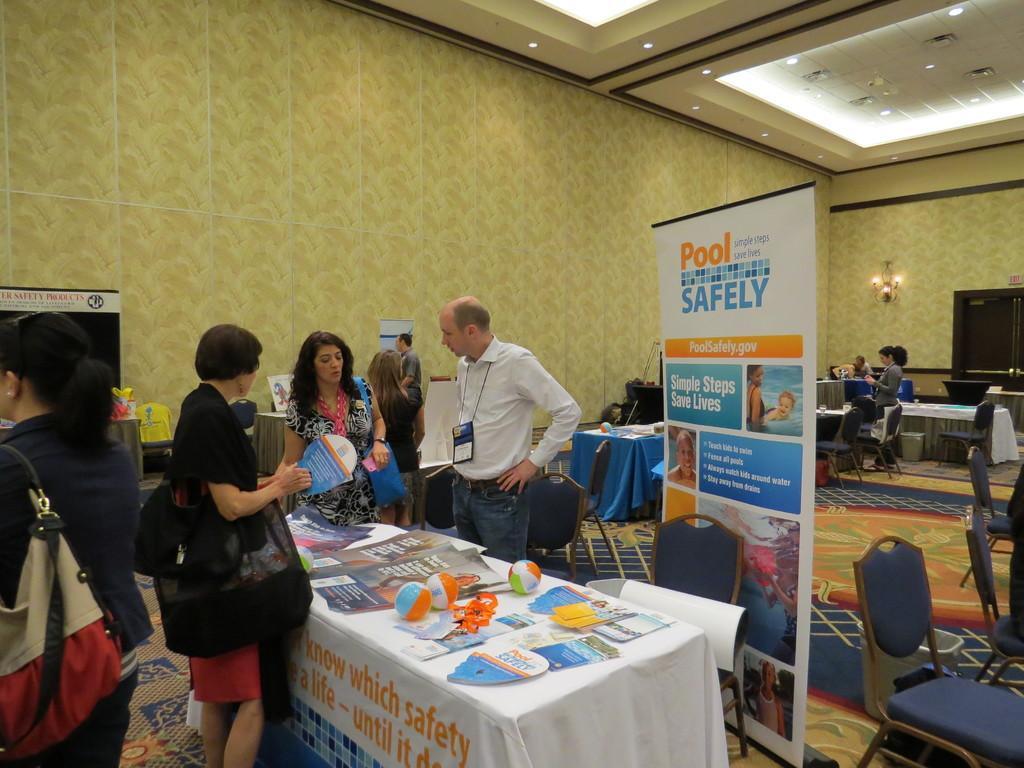Could you give a brief overview of what you see in this image? In this image we can see group of people standing on the floor, some are carrying bags. In the foreground of the image we can see papers , balls placed on the table. In the right side of the image we can see a banner with some text. In the background we can see lights on wall and a door. 